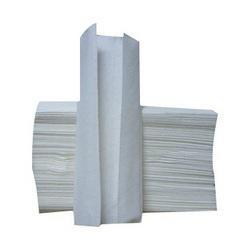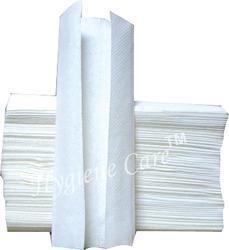The first image is the image on the left, the second image is the image on the right. Examine the images to the left and right. Is the description "At least one image shows an upright roll of white towels on a stand." accurate? Answer yes or no. No. The first image is the image on the left, the second image is the image on the right. For the images displayed, is the sentence "In one image, a stack of folded paper towels is angled so the narrow end of the stack is visible, and one paper towel is displayed partially opened." factually correct? Answer yes or no. No. 